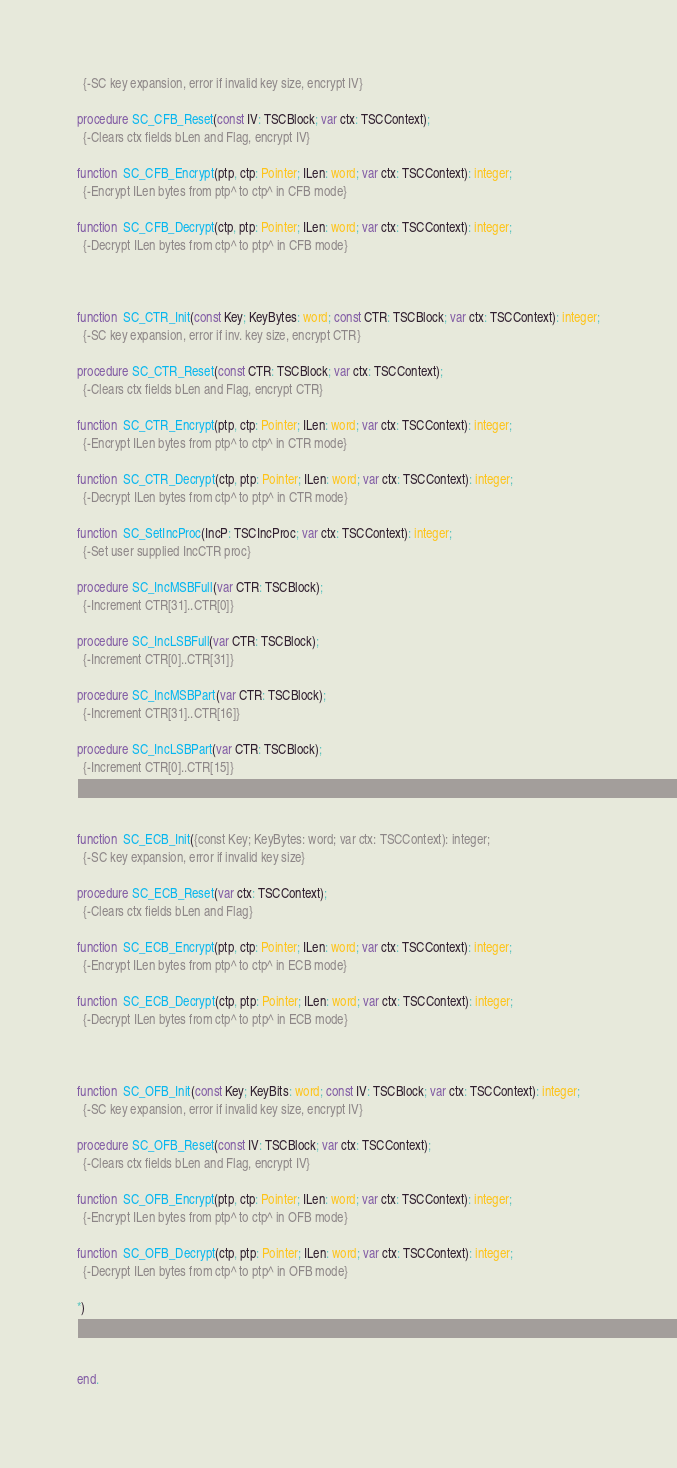Convert code to text. <code><loc_0><loc_0><loc_500><loc_500><_Pascal_>  {-SC key expansion, error if invalid key size, encrypt IV}

procedure SC_CFB_Reset(const IV: TSCBlock; var ctx: TSCContext);
  {-Clears ctx fields bLen and Flag, encrypt IV}

function  SC_CFB_Encrypt(ptp, ctp: Pointer; ILen: word; var ctx: TSCContext): integer;
  {-Encrypt ILen bytes from ptp^ to ctp^ in CFB mode}

function  SC_CFB_Decrypt(ctp, ptp: Pointer; ILen: word; var ctx: TSCContext): integer;
  {-Decrypt ILen bytes from ctp^ to ptp^ in CFB mode}



function  SC_CTR_Init(const Key; KeyBytes: word; const CTR: TSCBlock; var ctx: TSCContext): integer;
  {-SC key expansion, error if inv. key size, encrypt CTR}

procedure SC_CTR_Reset(const CTR: TSCBlock; var ctx: TSCContext);
  {-Clears ctx fields bLen and Flag, encrypt CTR}

function  SC_CTR_Encrypt(ptp, ctp: Pointer; ILen: word; var ctx: TSCContext): integer;
  {-Encrypt ILen bytes from ptp^ to ctp^ in CTR mode}

function  SC_CTR_Decrypt(ctp, ptp: Pointer; ILen: word; var ctx: TSCContext): integer;
  {-Decrypt ILen bytes from ctp^ to ptp^ in CTR mode}

function  SC_SetIncProc(IncP: TSCIncProc; var ctx: TSCContext): integer;
  {-Set user supplied IncCTR proc}

procedure SC_IncMSBFull(var CTR: TSCBlock);
  {-Increment CTR[31]..CTR[0]}

procedure SC_IncLSBFull(var CTR: TSCBlock);
  {-Increment CTR[0]..CTR[31]}

procedure SC_IncMSBPart(var CTR: TSCBlock);
  {-Increment CTR[31]..CTR[16]}

procedure SC_IncLSBPart(var CTR: TSCBlock);
  {-Increment CTR[0]..CTR[15]}



function  SC_ECB_Init({const Key; KeyBytes: word; var ctx: TSCContext): integer;
  {-SC key expansion, error if invalid key size}

procedure SC_ECB_Reset(var ctx: TSCContext);
  {-Clears ctx fields bLen and Flag}

function  SC_ECB_Encrypt(ptp, ctp: Pointer; ILen: word; var ctx: TSCContext): integer;
  {-Encrypt ILen bytes from ptp^ to ctp^ in ECB mode}

function  SC_ECB_Decrypt(ctp, ptp: Pointer; ILen: word; var ctx: TSCContext): integer;
  {-Decrypt ILen bytes from ctp^ to ptp^ in ECB mode}



function  SC_OFB_Init(const Key; KeyBits: word; const IV: TSCBlock; var ctx: TSCContext): integer;
  {-SC key expansion, error if invalid key size, encrypt IV}

procedure SC_OFB_Reset(const IV: TSCBlock; var ctx: TSCContext);
  {-Clears ctx fields bLen and Flag, encrypt IV}

function  SC_OFB_Encrypt(ptp, ctp: Pointer; ILen: word; var ctx: TSCContext): integer;
  {-Encrypt ILen bytes from ptp^ to ctp^ in OFB mode}

function  SC_OFB_Decrypt(ctp, ptp: Pointer; ILen: word; var ctx: TSCContext): integer;
  {-Decrypt ILen bytes from ctp^ to ptp^ in OFB mode}

*)



end.

</code> 